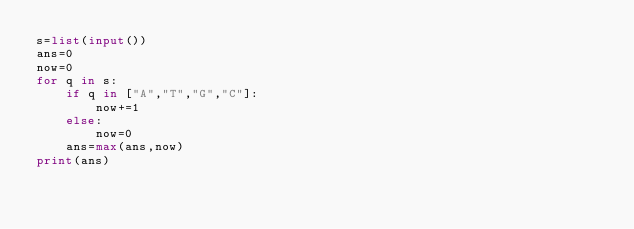Convert code to text. <code><loc_0><loc_0><loc_500><loc_500><_Python_>s=list(input())
ans=0
now=0
for q in s:
    if q in ["A","T","G","C"]:
        now+=1
    else:
        now=0
    ans=max(ans,now)
print(ans)</code> 